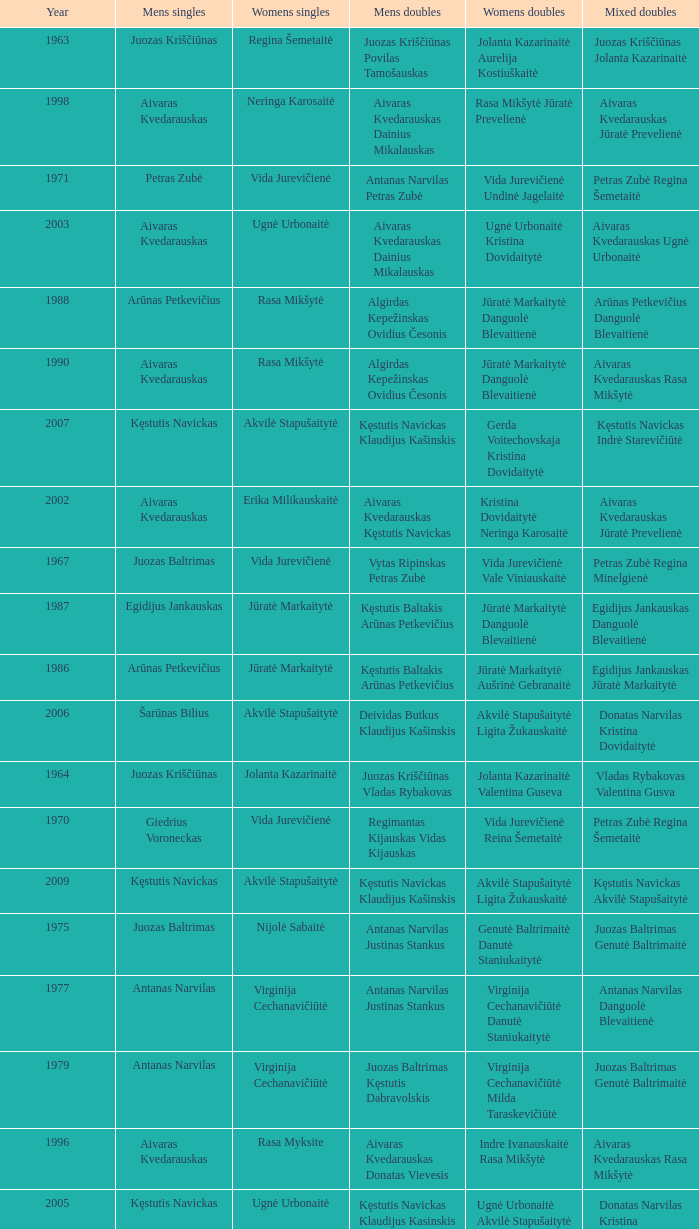What was the first year of the Lithuanian National Badminton Championships? 1963.0. 